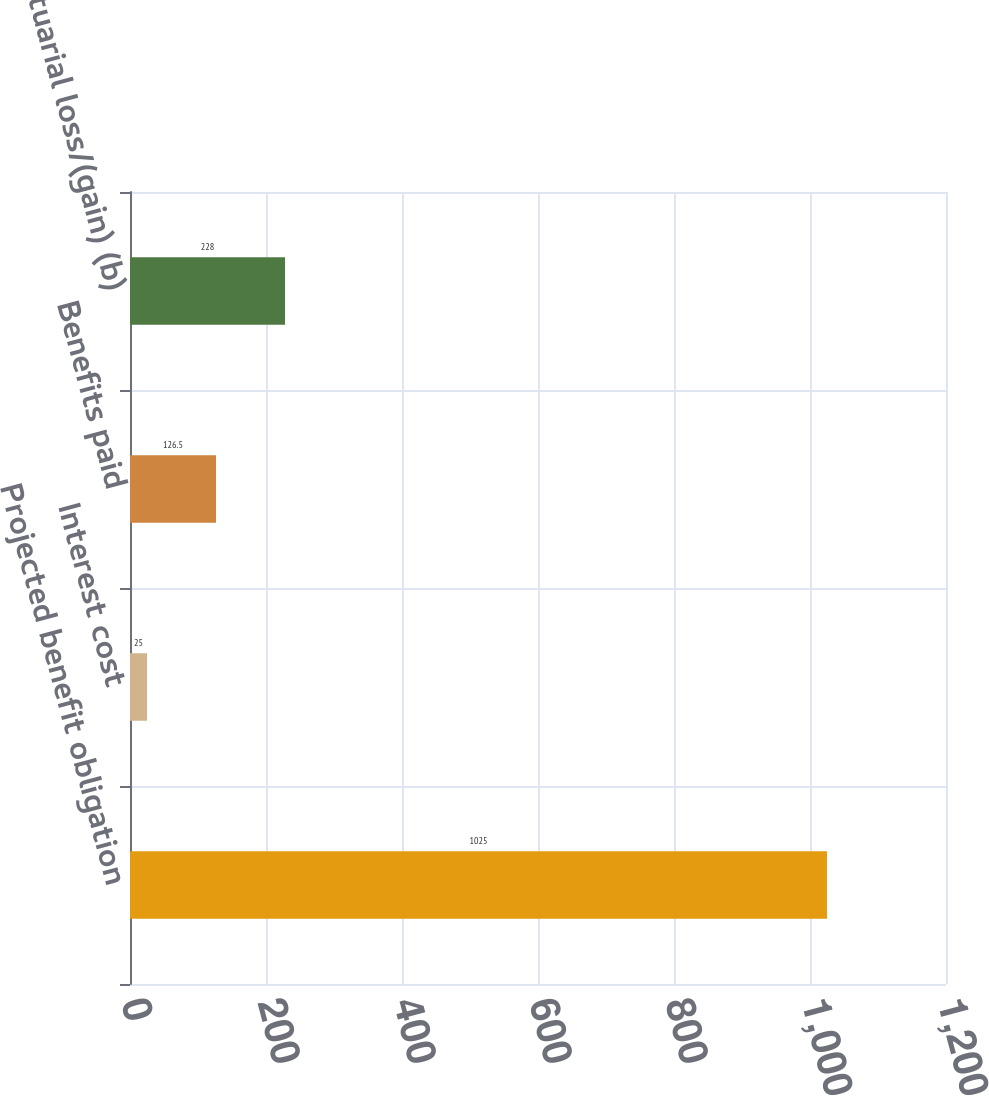Convert chart to OTSL. <chart><loc_0><loc_0><loc_500><loc_500><bar_chart><fcel>Projected benefit obligation<fcel>Interest cost<fcel>Benefits paid<fcel>Actuarial loss/(gain) (b)<nl><fcel>1025<fcel>25<fcel>126.5<fcel>228<nl></chart> 